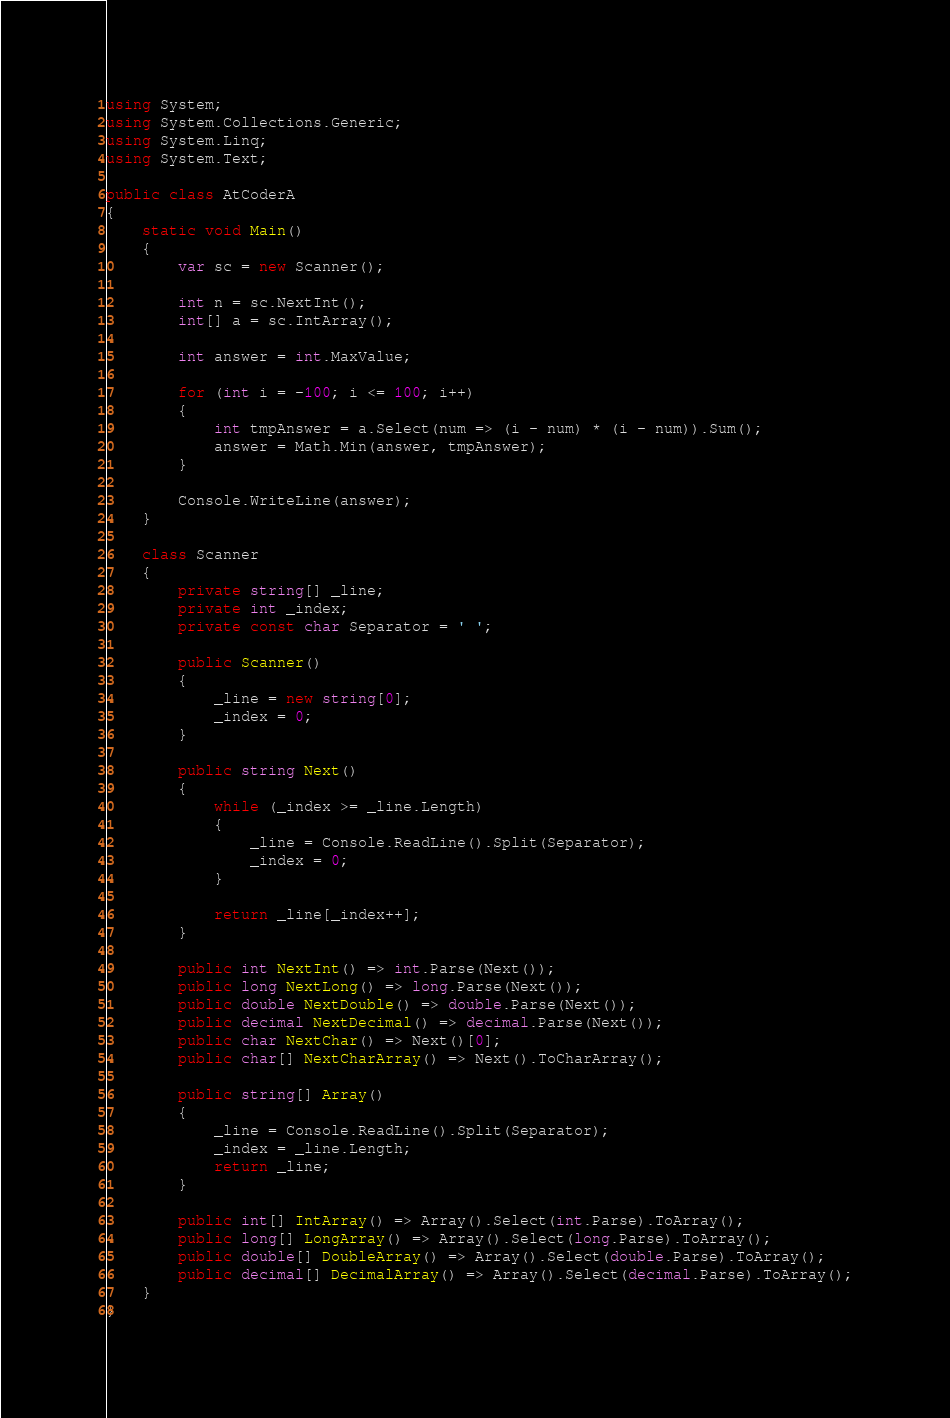Convert code to text. <code><loc_0><loc_0><loc_500><loc_500><_C#_>using System;
using System.Collections.Generic;
using System.Linq;
using System.Text;

public class AtCoderA
{
    static void Main()
    {
        var sc = new Scanner();

        int n = sc.NextInt();
        int[] a = sc.IntArray();

        int answer = int.MaxValue;

        for (int i = -100; i <= 100; i++)
        {
            int tmpAnswer = a.Select(num => (i - num) * (i - num)).Sum();
            answer = Math.Min(answer, tmpAnswer);
        }

        Console.WriteLine(answer);
    }

    class Scanner
    {
        private string[] _line;
        private int _index;
        private const char Separator = ' ';

        public Scanner()
        {
            _line = new string[0];
            _index = 0;
        }

        public string Next()
        {
            while (_index >= _line.Length)
            {
                _line = Console.ReadLine().Split(Separator);
                _index = 0;
            }

            return _line[_index++];
        }

        public int NextInt() => int.Parse(Next());
        public long NextLong() => long.Parse(Next());
        public double NextDouble() => double.Parse(Next());
        public decimal NextDecimal() => decimal.Parse(Next());
        public char NextChar() => Next()[0];
        public char[] NextCharArray() => Next().ToCharArray();

        public string[] Array()
        {
            _line = Console.ReadLine().Split(Separator);
            _index = _line.Length;
            return _line;
        }

        public int[] IntArray() => Array().Select(int.Parse).ToArray();
        public long[] LongArray() => Array().Select(long.Parse).ToArray();
        public double[] DoubleArray() => Array().Select(double.Parse).ToArray();
        public decimal[] DecimalArray() => Array().Select(decimal.Parse).ToArray();
    }
}</code> 